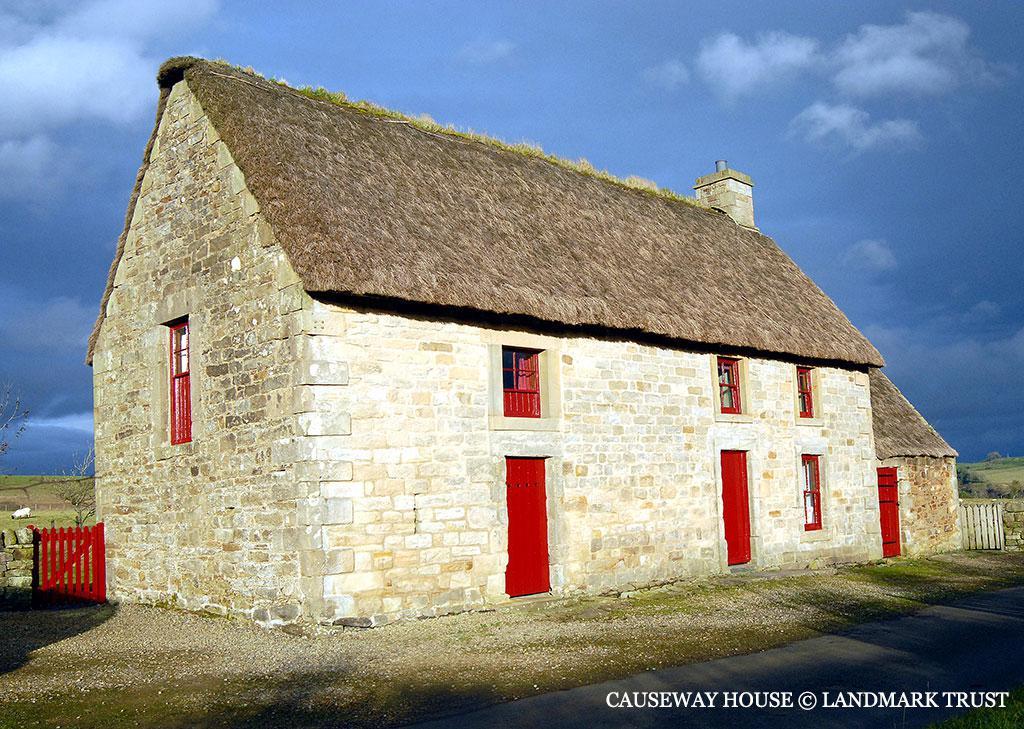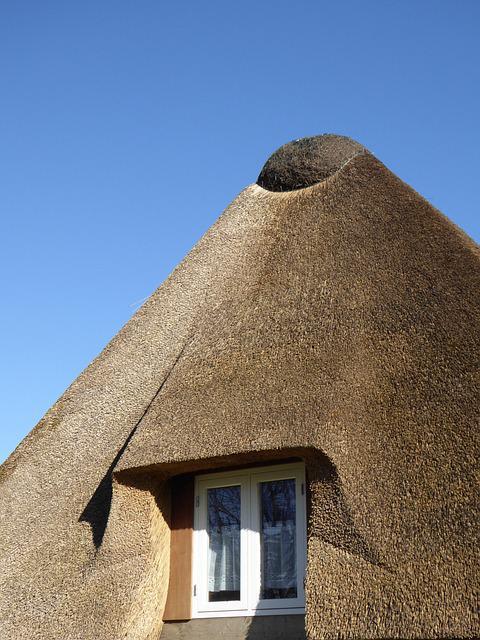The first image is the image on the left, the second image is the image on the right. Given the left and right images, does the statement "One image shows a building with a thatched roof that does not extend all the way down its front, and the roof has three notched sections to accommodate upper story windows." hold true? Answer yes or no. No. The first image is the image on the left, the second image is the image on the right. Analyze the images presented: Is the assertion "A fence runs alongside the building in the image on the left." valid? Answer yes or no. No. 